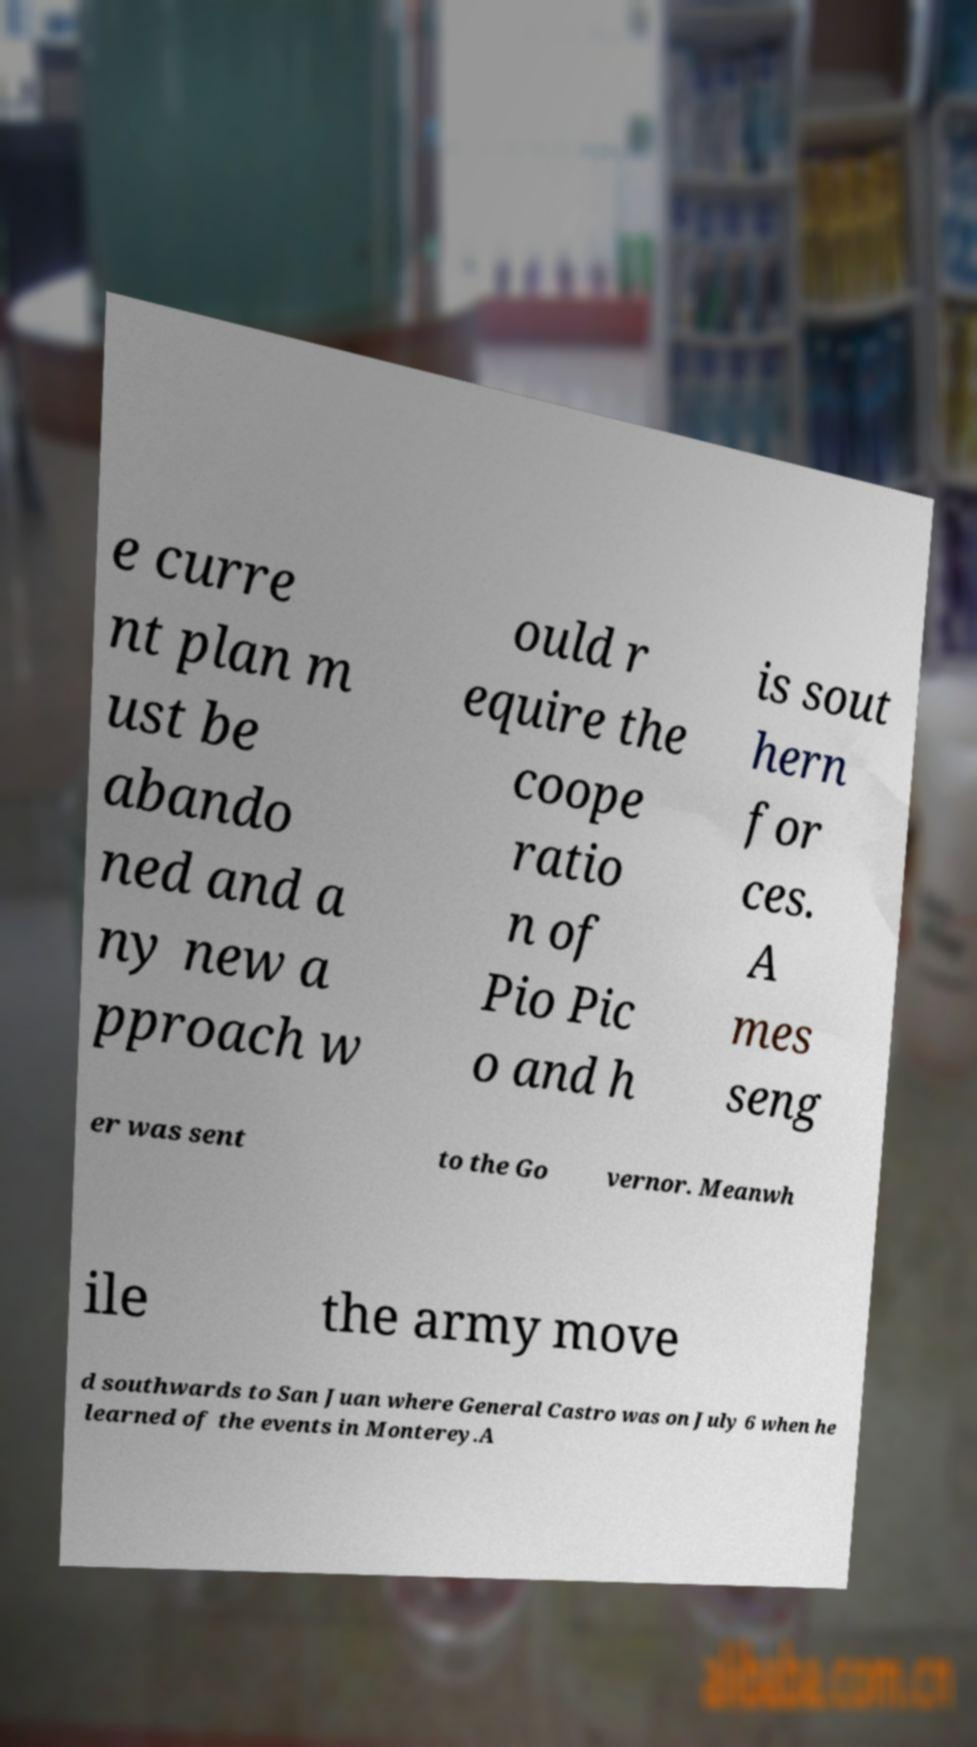There's text embedded in this image that I need extracted. Can you transcribe it verbatim? e curre nt plan m ust be abando ned and a ny new a pproach w ould r equire the coope ratio n of Pio Pic o and h is sout hern for ces. A mes seng er was sent to the Go vernor. Meanwh ile the army move d southwards to San Juan where General Castro was on July 6 when he learned of the events in Monterey.A 